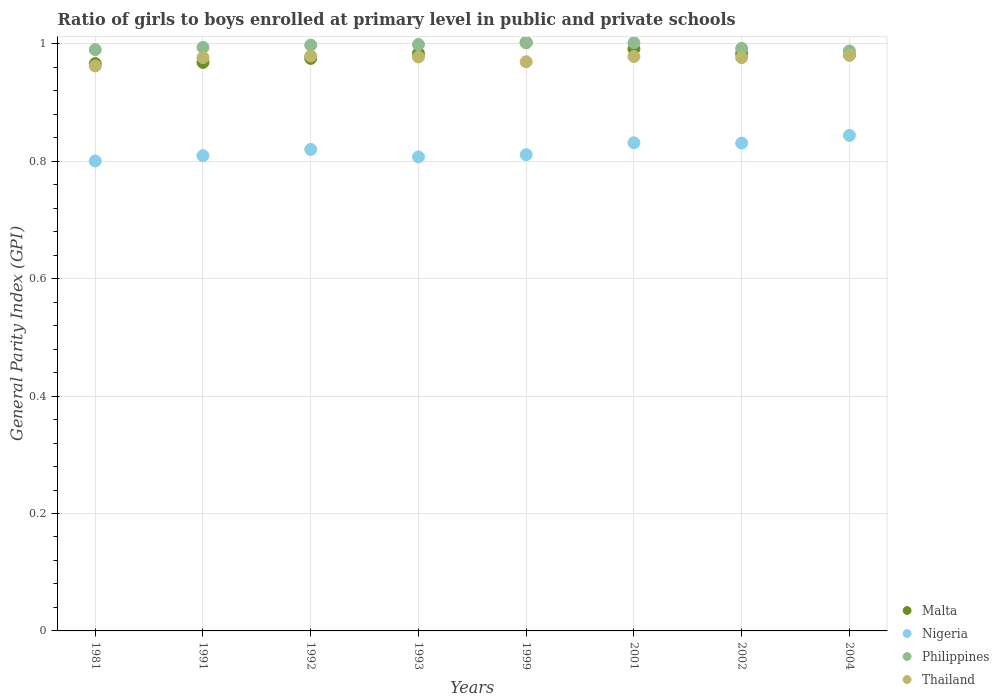What is the general parity index in Philippines in 2004?
Offer a very short reply. 0.99. Across all years, what is the maximum general parity index in Philippines?
Your answer should be compact. 1. Across all years, what is the minimum general parity index in Malta?
Ensure brevity in your answer.  0.97. In which year was the general parity index in Malta maximum?
Your answer should be compact. 1999. In which year was the general parity index in Philippines minimum?
Your answer should be very brief. 2004. What is the total general parity index in Malta in the graph?
Give a very brief answer. 7.85. What is the difference between the general parity index in Nigeria in 1991 and that in 1992?
Offer a terse response. -0.01. What is the difference between the general parity index in Thailand in 1993 and the general parity index in Philippines in 2001?
Keep it short and to the point. -0.02. What is the average general parity index in Thailand per year?
Provide a succinct answer. 0.98. In the year 1981, what is the difference between the general parity index in Philippines and general parity index in Nigeria?
Your answer should be compact. 0.19. In how many years, is the general parity index in Malta greater than 0.9600000000000001?
Your answer should be compact. 8. What is the ratio of the general parity index in Malta in 1981 to that in 1999?
Offer a very short reply. 0.96. Is the difference between the general parity index in Philippines in 1981 and 1993 greater than the difference between the general parity index in Nigeria in 1981 and 1993?
Provide a succinct answer. No. What is the difference between the highest and the second highest general parity index in Philippines?
Your response must be concise. 0. What is the difference between the highest and the lowest general parity index in Malta?
Provide a short and direct response. 0.04. Is the sum of the general parity index in Philippines in 1992 and 2001 greater than the maximum general parity index in Nigeria across all years?
Ensure brevity in your answer.  Yes. Is it the case that in every year, the sum of the general parity index in Malta and general parity index in Thailand  is greater than the sum of general parity index in Philippines and general parity index in Nigeria?
Ensure brevity in your answer.  Yes. How many dotlines are there?
Give a very brief answer. 4. What is the difference between two consecutive major ticks on the Y-axis?
Keep it short and to the point. 0.2. How are the legend labels stacked?
Your answer should be very brief. Vertical. What is the title of the graph?
Keep it short and to the point. Ratio of girls to boys enrolled at primary level in public and private schools. What is the label or title of the Y-axis?
Provide a succinct answer. General Parity Index (GPI). What is the General Parity Index (GPI) of Malta in 1981?
Give a very brief answer. 0.97. What is the General Parity Index (GPI) in Nigeria in 1981?
Your response must be concise. 0.8. What is the General Parity Index (GPI) of Philippines in 1981?
Keep it short and to the point. 0.99. What is the General Parity Index (GPI) in Thailand in 1981?
Your response must be concise. 0.96. What is the General Parity Index (GPI) in Malta in 1991?
Your answer should be very brief. 0.97. What is the General Parity Index (GPI) in Nigeria in 1991?
Your answer should be compact. 0.81. What is the General Parity Index (GPI) of Philippines in 1991?
Provide a short and direct response. 0.99. What is the General Parity Index (GPI) of Thailand in 1991?
Provide a succinct answer. 0.98. What is the General Parity Index (GPI) of Malta in 1992?
Give a very brief answer. 0.98. What is the General Parity Index (GPI) of Nigeria in 1992?
Keep it short and to the point. 0.82. What is the General Parity Index (GPI) in Philippines in 1992?
Offer a terse response. 1. What is the General Parity Index (GPI) in Thailand in 1992?
Offer a very short reply. 0.98. What is the General Parity Index (GPI) of Malta in 1993?
Give a very brief answer. 0.98. What is the General Parity Index (GPI) of Nigeria in 1993?
Offer a very short reply. 0.81. What is the General Parity Index (GPI) in Philippines in 1993?
Your answer should be very brief. 1. What is the General Parity Index (GPI) of Thailand in 1993?
Your response must be concise. 0.98. What is the General Parity Index (GPI) in Malta in 1999?
Your answer should be very brief. 1. What is the General Parity Index (GPI) of Nigeria in 1999?
Your answer should be compact. 0.81. What is the General Parity Index (GPI) of Philippines in 1999?
Your answer should be compact. 1. What is the General Parity Index (GPI) in Thailand in 1999?
Your answer should be very brief. 0.97. What is the General Parity Index (GPI) in Malta in 2001?
Ensure brevity in your answer.  0.99. What is the General Parity Index (GPI) in Nigeria in 2001?
Your response must be concise. 0.83. What is the General Parity Index (GPI) in Philippines in 2001?
Give a very brief answer. 1. What is the General Parity Index (GPI) in Thailand in 2001?
Ensure brevity in your answer.  0.98. What is the General Parity Index (GPI) in Malta in 2002?
Your answer should be very brief. 0.98. What is the General Parity Index (GPI) in Nigeria in 2002?
Offer a very short reply. 0.83. What is the General Parity Index (GPI) in Philippines in 2002?
Your response must be concise. 0.99. What is the General Parity Index (GPI) in Thailand in 2002?
Provide a short and direct response. 0.98. What is the General Parity Index (GPI) of Malta in 2004?
Your answer should be very brief. 0.98. What is the General Parity Index (GPI) of Nigeria in 2004?
Offer a terse response. 0.84. What is the General Parity Index (GPI) in Philippines in 2004?
Your response must be concise. 0.99. What is the General Parity Index (GPI) in Thailand in 2004?
Offer a terse response. 0.98. Across all years, what is the maximum General Parity Index (GPI) in Malta?
Ensure brevity in your answer.  1. Across all years, what is the maximum General Parity Index (GPI) of Nigeria?
Make the answer very short. 0.84. Across all years, what is the maximum General Parity Index (GPI) of Philippines?
Keep it short and to the point. 1. Across all years, what is the maximum General Parity Index (GPI) of Thailand?
Give a very brief answer. 0.98. Across all years, what is the minimum General Parity Index (GPI) in Malta?
Provide a succinct answer. 0.97. Across all years, what is the minimum General Parity Index (GPI) of Nigeria?
Your response must be concise. 0.8. Across all years, what is the minimum General Parity Index (GPI) of Philippines?
Make the answer very short. 0.99. Across all years, what is the minimum General Parity Index (GPI) of Thailand?
Your answer should be very brief. 0.96. What is the total General Parity Index (GPI) of Malta in the graph?
Offer a terse response. 7.85. What is the total General Parity Index (GPI) of Nigeria in the graph?
Provide a short and direct response. 6.55. What is the total General Parity Index (GPI) in Philippines in the graph?
Provide a succinct answer. 7.96. What is the total General Parity Index (GPI) of Thailand in the graph?
Your response must be concise. 7.8. What is the difference between the General Parity Index (GPI) in Malta in 1981 and that in 1991?
Provide a short and direct response. -0. What is the difference between the General Parity Index (GPI) in Nigeria in 1981 and that in 1991?
Provide a short and direct response. -0.01. What is the difference between the General Parity Index (GPI) in Philippines in 1981 and that in 1991?
Offer a very short reply. -0. What is the difference between the General Parity Index (GPI) of Thailand in 1981 and that in 1991?
Give a very brief answer. -0.01. What is the difference between the General Parity Index (GPI) in Malta in 1981 and that in 1992?
Your response must be concise. -0.01. What is the difference between the General Parity Index (GPI) of Nigeria in 1981 and that in 1992?
Provide a succinct answer. -0.02. What is the difference between the General Parity Index (GPI) of Philippines in 1981 and that in 1992?
Ensure brevity in your answer.  -0.01. What is the difference between the General Parity Index (GPI) of Thailand in 1981 and that in 1992?
Provide a short and direct response. -0.02. What is the difference between the General Parity Index (GPI) of Malta in 1981 and that in 1993?
Provide a short and direct response. -0.02. What is the difference between the General Parity Index (GPI) of Nigeria in 1981 and that in 1993?
Give a very brief answer. -0.01. What is the difference between the General Parity Index (GPI) of Philippines in 1981 and that in 1993?
Offer a terse response. -0.01. What is the difference between the General Parity Index (GPI) of Thailand in 1981 and that in 1993?
Your answer should be compact. -0.02. What is the difference between the General Parity Index (GPI) in Malta in 1981 and that in 1999?
Keep it short and to the point. -0.04. What is the difference between the General Parity Index (GPI) in Nigeria in 1981 and that in 1999?
Provide a short and direct response. -0.01. What is the difference between the General Parity Index (GPI) in Philippines in 1981 and that in 1999?
Give a very brief answer. -0.01. What is the difference between the General Parity Index (GPI) of Thailand in 1981 and that in 1999?
Give a very brief answer. -0.01. What is the difference between the General Parity Index (GPI) in Malta in 1981 and that in 2001?
Provide a short and direct response. -0.03. What is the difference between the General Parity Index (GPI) in Nigeria in 1981 and that in 2001?
Offer a terse response. -0.03. What is the difference between the General Parity Index (GPI) of Philippines in 1981 and that in 2001?
Provide a succinct answer. -0.01. What is the difference between the General Parity Index (GPI) of Thailand in 1981 and that in 2001?
Offer a very short reply. -0.02. What is the difference between the General Parity Index (GPI) of Malta in 1981 and that in 2002?
Make the answer very short. -0.02. What is the difference between the General Parity Index (GPI) of Nigeria in 1981 and that in 2002?
Provide a short and direct response. -0.03. What is the difference between the General Parity Index (GPI) of Philippines in 1981 and that in 2002?
Keep it short and to the point. -0. What is the difference between the General Parity Index (GPI) in Thailand in 1981 and that in 2002?
Keep it short and to the point. -0.01. What is the difference between the General Parity Index (GPI) in Malta in 1981 and that in 2004?
Offer a terse response. -0.01. What is the difference between the General Parity Index (GPI) in Nigeria in 1981 and that in 2004?
Offer a terse response. -0.04. What is the difference between the General Parity Index (GPI) of Philippines in 1981 and that in 2004?
Provide a succinct answer. 0. What is the difference between the General Parity Index (GPI) of Thailand in 1981 and that in 2004?
Ensure brevity in your answer.  -0.02. What is the difference between the General Parity Index (GPI) of Malta in 1991 and that in 1992?
Your response must be concise. -0.01. What is the difference between the General Parity Index (GPI) of Nigeria in 1991 and that in 1992?
Provide a succinct answer. -0.01. What is the difference between the General Parity Index (GPI) in Philippines in 1991 and that in 1992?
Keep it short and to the point. -0. What is the difference between the General Parity Index (GPI) in Thailand in 1991 and that in 1992?
Your answer should be compact. -0. What is the difference between the General Parity Index (GPI) in Malta in 1991 and that in 1993?
Offer a very short reply. -0.02. What is the difference between the General Parity Index (GPI) in Nigeria in 1991 and that in 1993?
Offer a terse response. 0. What is the difference between the General Parity Index (GPI) of Philippines in 1991 and that in 1993?
Give a very brief answer. -0.01. What is the difference between the General Parity Index (GPI) of Thailand in 1991 and that in 1993?
Your answer should be compact. -0. What is the difference between the General Parity Index (GPI) in Malta in 1991 and that in 1999?
Provide a succinct answer. -0.03. What is the difference between the General Parity Index (GPI) in Nigeria in 1991 and that in 1999?
Provide a short and direct response. -0. What is the difference between the General Parity Index (GPI) in Philippines in 1991 and that in 1999?
Offer a terse response. -0.01. What is the difference between the General Parity Index (GPI) in Thailand in 1991 and that in 1999?
Your response must be concise. 0.01. What is the difference between the General Parity Index (GPI) of Malta in 1991 and that in 2001?
Offer a very short reply. -0.02. What is the difference between the General Parity Index (GPI) of Nigeria in 1991 and that in 2001?
Give a very brief answer. -0.02. What is the difference between the General Parity Index (GPI) of Philippines in 1991 and that in 2001?
Offer a very short reply. -0.01. What is the difference between the General Parity Index (GPI) of Thailand in 1991 and that in 2001?
Your response must be concise. -0. What is the difference between the General Parity Index (GPI) in Malta in 1991 and that in 2002?
Provide a succinct answer. -0.01. What is the difference between the General Parity Index (GPI) in Nigeria in 1991 and that in 2002?
Provide a short and direct response. -0.02. What is the difference between the General Parity Index (GPI) of Philippines in 1991 and that in 2002?
Give a very brief answer. 0. What is the difference between the General Parity Index (GPI) of Thailand in 1991 and that in 2002?
Your answer should be compact. 0. What is the difference between the General Parity Index (GPI) in Malta in 1991 and that in 2004?
Your response must be concise. -0.01. What is the difference between the General Parity Index (GPI) in Nigeria in 1991 and that in 2004?
Provide a short and direct response. -0.03. What is the difference between the General Parity Index (GPI) in Philippines in 1991 and that in 2004?
Your answer should be compact. 0.01. What is the difference between the General Parity Index (GPI) of Thailand in 1991 and that in 2004?
Make the answer very short. -0. What is the difference between the General Parity Index (GPI) in Malta in 1992 and that in 1993?
Your answer should be compact. -0.01. What is the difference between the General Parity Index (GPI) of Nigeria in 1992 and that in 1993?
Ensure brevity in your answer.  0.01. What is the difference between the General Parity Index (GPI) of Philippines in 1992 and that in 1993?
Provide a short and direct response. -0. What is the difference between the General Parity Index (GPI) in Thailand in 1992 and that in 1993?
Offer a very short reply. 0. What is the difference between the General Parity Index (GPI) of Malta in 1992 and that in 1999?
Your answer should be very brief. -0.03. What is the difference between the General Parity Index (GPI) in Nigeria in 1992 and that in 1999?
Provide a short and direct response. 0.01. What is the difference between the General Parity Index (GPI) in Philippines in 1992 and that in 1999?
Ensure brevity in your answer.  -0. What is the difference between the General Parity Index (GPI) in Thailand in 1992 and that in 1999?
Your answer should be compact. 0.01. What is the difference between the General Parity Index (GPI) in Malta in 1992 and that in 2001?
Offer a very short reply. -0.02. What is the difference between the General Parity Index (GPI) of Nigeria in 1992 and that in 2001?
Make the answer very short. -0.01. What is the difference between the General Parity Index (GPI) of Philippines in 1992 and that in 2001?
Offer a very short reply. -0. What is the difference between the General Parity Index (GPI) of Thailand in 1992 and that in 2001?
Your response must be concise. 0. What is the difference between the General Parity Index (GPI) of Malta in 1992 and that in 2002?
Provide a short and direct response. -0.01. What is the difference between the General Parity Index (GPI) in Nigeria in 1992 and that in 2002?
Offer a terse response. -0.01. What is the difference between the General Parity Index (GPI) in Philippines in 1992 and that in 2002?
Your answer should be very brief. 0.01. What is the difference between the General Parity Index (GPI) in Thailand in 1992 and that in 2002?
Provide a short and direct response. 0. What is the difference between the General Parity Index (GPI) in Malta in 1992 and that in 2004?
Make the answer very short. -0.01. What is the difference between the General Parity Index (GPI) of Nigeria in 1992 and that in 2004?
Keep it short and to the point. -0.02. What is the difference between the General Parity Index (GPI) in Philippines in 1992 and that in 2004?
Your answer should be very brief. 0.01. What is the difference between the General Parity Index (GPI) in Thailand in 1992 and that in 2004?
Ensure brevity in your answer.  -0. What is the difference between the General Parity Index (GPI) in Malta in 1993 and that in 1999?
Make the answer very short. -0.02. What is the difference between the General Parity Index (GPI) in Nigeria in 1993 and that in 1999?
Your answer should be compact. -0. What is the difference between the General Parity Index (GPI) of Philippines in 1993 and that in 1999?
Keep it short and to the point. -0. What is the difference between the General Parity Index (GPI) of Thailand in 1993 and that in 1999?
Make the answer very short. 0.01. What is the difference between the General Parity Index (GPI) in Malta in 1993 and that in 2001?
Offer a terse response. -0.01. What is the difference between the General Parity Index (GPI) of Nigeria in 1993 and that in 2001?
Provide a succinct answer. -0.02. What is the difference between the General Parity Index (GPI) in Philippines in 1993 and that in 2001?
Ensure brevity in your answer.  -0. What is the difference between the General Parity Index (GPI) in Thailand in 1993 and that in 2001?
Provide a short and direct response. -0. What is the difference between the General Parity Index (GPI) in Nigeria in 1993 and that in 2002?
Your response must be concise. -0.02. What is the difference between the General Parity Index (GPI) of Philippines in 1993 and that in 2002?
Your answer should be compact. 0.01. What is the difference between the General Parity Index (GPI) of Thailand in 1993 and that in 2002?
Offer a very short reply. 0. What is the difference between the General Parity Index (GPI) in Malta in 1993 and that in 2004?
Give a very brief answer. 0. What is the difference between the General Parity Index (GPI) in Nigeria in 1993 and that in 2004?
Offer a very short reply. -0.04. What is the difference between the General Parity Index (GPI) of Philippines in 1993 and that in 2004?
Ensure brevity in your answer.  0.01. What is the difference between the General Parity Index (GPI) of Thailand in 1993 and that in 2004?
Offer a very short reply. -0. What is the difference between the General Parity Index (GPI) of Malta in 1999 and that in 2001?
Provide a succinct answer. 0.01. What is the difference between the General Parity Index (GPI) in Nigeria in 1999 and that in 2001?
Keep it short and to the point. -0.02. What is the difference between the General Parity Index (GPI) in Thailand in 1999 and that in 2001?
Ensure brevity in your answer.  -0.01. What is the difference between the General Parity Index (GPI) in Malta in 1999 and that in 2002?
Your response must be concise. 0.02. What is the difference between the General Parity Index (GPI) in Nigeria in 1999 and that in 2002?
Provide a short and direct response. -0.02. What is the difference between the General Parity Index (GPI) in Philippines in 1999 and that in 2002?
Provide a succinct answer. 0.01. What is the difference between the General Parity Index (GPI) in Thailand in 1999 and that in 2002?
Give a very brief answer. -0.01. What is the difference between the General Parity Index (GPI) in Malta in 1999 and that in 2004?
Your response must be concise. 0.02. What is the difference between the General Parity Index (GPI) of Nigeria in 1999 and that in 2004?
Keep it short and to the point. -0.03. What is the difference between the General Parity Index (GPI) in Philippines in 1999 and that in 2004?
Keep it short and to the point. 0.01. What is the difference between the General Parity Index (GPI) in Thailand in 1999 and that in 2004?
Give a very brief answer. -0.01. What is the difference between the General Parity Index (GPI) of Malta in 2001 and that in 2002?
Your response must be concise. 0.01. What is the difference between the General Parity Index (GPI) of Nigeria in 2001 and that in 2002?
Ensure brevity in your answer.  0. What is the difference between the General Parity Index (GPI) of Philippines in 2001 and that in 2002?
Provide a succinct answer. 0.01. What is the difference between the General Parity Index (GPI) in Thailand in 2001 and that in 2002?
Provide a short and direct response. 0. What is the difference between the General Parity Index (GPI) in Malta in 2001 and that in 2004?
Give a very brief answer. 0.01. What is the difference between the General Parity Index (GPI) of Nigeria in 2001 and that in 2004?
Offer a terse response. -0.01. What is the difference between the General Parity Index (GPI) in Philippines in 2001 and that in 2004?
Your response must be concise. 0.01. What is the difference between the General Parity Index (GPI) in Thailand in 2001 and that in 2004?
Give a very brief answer. -0. What is the difference between the General Parity Index (GPI) in Malta in 2002 and that in 2004?
Provide a succinct answer. 0. What is the difference between the General Parity Index (GPI) of Nigeria in 2002 and that in 2004?
Your answer should be very brief. -0.01. What is the difference between the General Parity Index (GPI) in Philippines in 2002 and that in 2004?
Your answer should be very brief. 0. What is the difference between the General Parity Index (GPI) in Thailand in 2002 and that in 2004?
Ensure brevity in your answer.  -0. What is the difference between the General Parity Index (GPI) in Malta in 1981 and the General Parity Index (GPI) in Nigeria in 1991?
Keep it short and to the point. 0.16. What is the difference between the General Parity Index (GPI) in Malta in 1981 and the General Parity Index (GPI) in Philippines in 1991?
Provide a short and direct response. -0.03. What is the difference between the General Parity Index (GPI) of Malta in 1981 and the General Parity Index (GPI) of Thailand in 1991?
Ensure brevity in your answer.  -0.01. What is the difference between the General Parity Index (GPI) of Nigeria in 1981 and the General Parity Index (GPI) of Philippines in 1991?
Give a very brief answer. -0.19. What is the difference between the General Parity Index (GPI) of Nigeria in 1981 and the General Parity Index (GPI) of Thailand in 1991?
Your answer should be compact. -0.18. What is the difference between the General Parity Index (GPI) of Philippines in 1981 and the General Parity Index (GPI) of Thailand in 1991?
Offer a terse response. 0.01. What is the difference between the General Parity Index (GPI) in Malta in 1981 and the General Parity Index (GPI) in Nigeria in 1992?
Your answer should be very brief. 0.15. What is the difference between the General Parity Index (GPI) in Malta in 1981 and the General Parity Index (GPI) in Philippines in 1992?
Offer a very short reply. -0.03. What is the difference between the General Parity Index (GPI) in Malta in 1981 and the General Parity Index (GPI) in Thailand in 1992?
Your answer should be very brief. -0.01. What is the difference between the General Parity Index (GPI) in Nigeria in 1981 and the General Parity Index (GPI) in Philippines in 1992?
Ensure brevity in your answer.  -0.2. What is the difference between the General Parity Index (GPI) of Nigeria in 1981 and the General Parity Index (GPI) of Thailand in 1992?
Give a very brief answer. -0.18. What is the difference between the General Parity Index (GPI) in Philippines in 1981 and the General Parity Index (GPI) in Thailand in 1992?
Your answer should be very brief. 0.01. What is the difference between the General Parity Index (GPI) of Malta in 1981 and the General Parity Index (GPI) of Nigeria in 1993?
Offer a terse response. 0.16. What is the difference between the General Parity Index (GPI) in Malta in 1981 and the General Parity Index (GPI) in Philippines in 1993?
Make the answer very short. -0.03. What is the difference between the General Parity Index (GPI) of Malta in 1981 and the General Parity Index (GPI) of Thailand in 1993?
Provide a succinct answer. -0.01. What is the difference between the General Parity Index (GPI) in Nigeria in 1981 and the General Parity Index (GPI) in Philippines in 1993?
Provide a short and direct response. -0.2. What is the difference between the General Parity Index (GPI) in Nigeria in 1981 and the General Parity Index (GPI) in Thailand in 1993?
Offer a very short reply. -0.18. What is the difference between the General Parity Index (GPI) in Philippines in 1981 and the General Parity Index (GPI) in Thailand in 1993?
Offer a very short reply. 0.01. What is the difference between the General Parity Index (GPI) in Malta in 1981 and the General Parity Index (GPI) in Nigeria in 1999?
Keep it short and to the point. 0.15. What is the difference between the General Parity Index (GPI) of Malta in 1981 and the General Parity Index (GPI) of Philippines in 1999?
Provide a succinct answer. -0.04. What is the difference between the General Parity Index (GPI) of Malta in 1981 and the General Parity Index (GPI) of Thailand in 1999?
Keep it short and to the point. -0. What is the difference between the General Parity Index (GPI) in Nigeria in 1981 and the General Parity Index (GPI) in Philippines in 1999?
Offer a very short reply. -0.2. What is the difference between the General Parity Index (GPI) in Nigeria in 1981 and the General Parity Index (GPI) in Thailand in 1999?
Provide a succinct answer. -0.17. What is the difference between the General Parity Index (GPI) in Philippines in 1981 and the General Parity Index (GPI) in Thailand in 1999?
Give a very brief answer. 0.02. What is the difference between the General Parity Index (GPI) in Malta in 1981 and the General Parity Index (GPI) in Nigeria in 2001?
Give a very brief answer. 0.13. What is the difference between the General Parity Index (GPI) in Malta in 1981 and the General Parity Index (GPI) in Philippines in 2001?
Your answer should be compact. -0.04. What is the difference between the General Parity Index (GPI) of Malta in 1981 and the General Parity Index (GPI) of Thailand in 2001?
Make the answer very short. -0.01. What is the difference between the General Parity Index (GPI) in Nigeria in 1981 and the General Parity Index (GPI) in Philippines in 2001?
Your answer should be very brief. -0.2. What is the difference between the General Parity Index (GPI) of Nigeria in 1981 and the General Parity Index (GPI) of Thailand in 2001?
Your response must be concise. -0.18. What is the difference between the General Parity Index (GPI) of Philippines in 1981 and the General Parity Index (GPI) of Thailand in 2001?
Offer a very short reply. 0.01. What is the difference between the General Parity Index (GPI) in Malta in 1981 and the General Parity Index (GPI) in Nigeria in 2002?
Provide a succinct answer. 0.14. What is the difference between the General Parity Index (GPI) in Malta in 1981 and the General Parity Index (GPI) in Philippines in 2002?
Offer a terse response. -0.03. What is the difference between the General Parity Index (GPI) in Malta in 1981 and the General Parity Index (GPI) in Thailand in 2002?
Provide a succinct answer. -0.01. What is the difference between the General Parity Index (GPI) in Nigeria in 1981 and the General Parity Index (GPI) in Philippines in 2002?
Your answer should be compact. -0.19. What is the difference between the General Parity Index (GPI) in Nigeria in 1981 and the General Parity Index (GPI) in Thailand in 2002?
Make the answer very short. -0.18. What is the difference between the General Parity Index (GPI) in Philippines in 1981 and the General Parity Index (GPI) in Thailand in 2002?
Your answer should be compact. 0.01. What is the difference between the General Parity Index (GPI) in Malta in 1981 and the General Parity Index (GPI) in Nigeria in 2004?
Make the answer very short. 0.12. What is the difference between the General Parity Index (GPI) of Malta in 1981 and the General Parity Index (GPI) of Philippines in 2004?
Give a very brief answer. -0.02. What is the difference between the General Parity Index (GPI) of Malta in 1981 and the General Parity Index (GPI) of Thailand in 2004?
Your response must be concise. -0.01. What is the difference between the General Parity Index (GPI) in Nigeria in 1981 and the General Parity Index (GPI) in Philippines in 2004?
Ensure brevity in your answer.  -0.19. What is the difference between the General Parity Index (GPI) in Nigeria in 1981 and the General Parity Index (GPI) in Thailand in 2004?
Offer a very short reply. -0.18. What is the difference between the General Parity Index (GPI) of Philippines in 1981 and the General Parity Index (GPI) of Thailand in 2004?
Offer a very short reply. 0.01. What is the difference between the General Parity Index (GPI) of Malta in 1991 and the General Parity Index (GPI) of Nigeria in 1992?
Provide a succinct answer. 0.15. What is the difference between the General Parity Index (GPI) in Malta in 1991 and the General Parity Index (GPI) in Philippines in 1992?
Keep it short and to the point. -0.03. What is the difference between the General Parity Index (GPI) in Malta in 1991 and the General Parity Index (GPI) in Thailand in 1992?
Give a very brief answer. -0.01. What is the difference between the General Parity Index (GPI) in Nigeria in 1991 and the General Parity Index (GPI) in Philippines in 1992?
Keep it short and to the point. -0.19. What is the difference between the General Parity Index (GPI) of Nigeria in 1991 and the General Parity Index (GPI) of Thailand in 1992?
Your answer should be compact. -0.17. What is the difference between the General Parity Index (GPI) in Philippines in 1991 and the General Parity Index (GPI) in Thailand in 1992?
Offer a terse response. 0.01. What is the difference between the General Parity Index (GPI) in Malta in 1991 and the General Parity Index (GPI) in Nigeria in 1993?
Offer a very short reply. 0.16. What is the difference between the General Parity Index (GPI) of Malta in 1991 and the General Parity Index (GPI) of Philippines in 1993?
Keep it short and to the point. -0.03. What is the difference between the General Parity Index (GPI) in Malta in 1991 and the General Parity Index (GPI) in Thailand in 1993?
Provide a short and direct response. -0.01. What is the difference between the General Parity Index (GPI) of Nigeria in 1991 and the General Parity Index (GPI) of Philippines in 1993?
Provide a short and direct response. -0.19. What is the difference between the General Parity Index (GPI) of Nigeria in 1991 and the General Parity Index (GPI) of Thailand in 1993?
Keep it short and to the point. -0.17. What is the difference between the General Parity Index (GPI) in Philippines in 1991 and the General Parity Index (GPI) in Thailand in 1993?
Keep it short and to the point. 0.02. What is the difference between the General Parity Index (GPI) of Malta in 1991 and the General Parity Index (GPI) of Nigeria in 1999?
Provide a succinct answer. 0.16. What is the difference between the General Parity Index (GPI) of Malta in 1991 and the General Parity Index (GPI) of Philippines in 1999?
Ensure brevity in your answer.  -0.03. What is the difference between the General Parity Index (GPI) in Malta in 1991 and the General Parity Index (GPI) in Thailand in 1999?
Make the answer very short. -0. What is the difference between the General Parity Index (GPI) in Nigeria in 1991 and the General Parity Index (GPI) in Philippines in 1999?
Ensure brevity in your answer.  -0.19. What is the difference between the General Parity Index (GPI) in Nigeria in 1991 and the General Parity Index (GPI) in Thailand in 1999?
Offer a very short reply. -0.16. What is the difference between the General Parity Index (GPI) in Philippines in 1991 and the General Parity Index (GPI) in Thailand in 1999?
Your answer should be compact. 0.02. What is the difference between the General Parity Index (GPI) in Malta in 1991 and the General Parity Index (GPI) in Nigeria in 2001?
Offer a terse response. 0.14. What is the difference between the General Parity Index (GPI) of Malta in 1991 and the General Parity Index (GPI) of Philippines in 2001?
Offer a terse response. -0.03. What is the difference between the General Parity Index (GPI) in Malta in 1991 and the General Parity Index (GPI) in Thailand in 2001?
Offer a terse response. -0.01. What is the difference between the General Parity Index (GPI) of Nigeria in 1991 and the General Parity Index (GPI) of Philippines in 2001?
Your answer should be very brief. -0.19. What is the difference between the General Parity Index (GPI) in Nigeria in 1991 and the General Parity Index (GPI) in Thailand in 2001?
Keep it short and to the point. -0.17. What is the difference between the General Parity Index (GPI) of Philippines in 1991 and the General Parity Index (GPI) of Thailand in 2001?
Make the answer very short. 0.02. What is the difference between the General Parity Index (GPI) of Malta in 1991 and the General Parity Index (GPI) of Nigeria in 2002?
Your answer should be compact. 0.14. What is the difference between the General Parity Index (GPI) of Malta in 1991 and the General Parity Index (GPI) of Philippines in 2002?
Keep it short and to the point. -0.02. What is the difference between the General Parity Index (GPI) of Malta in 1991 and the General Parity Index (GPI) of Thailand in 2002?
Give a very brief answer. -0.01. What is the difference between the General Parity Index (GPI) in Nigeria in 1991 and the General Parity Index (GPI) in Philippines in 2002?
Give a very brief answer. -0.18. What is the difference between the General Parity Index (GPI) in Nigeria in 1991 and the General Parity Index (GPI) in Thailand in 2002?
Your answer should be compact. -0.17. What is the difference between the General Parity Index (GPI) of Philippines in 1991 and the General Parity Index (GPI) of Thailand in 2002?
Give a very brief answer. 0.02. What is the difference between the General Parity Index (GPI) of Malta in 1991 and the General Parity Index (GPI) of Nigeria in 2004?
Your answer should be compact. 0.12. What is the difference between the General Parity Index (GPI) in Malta in 1991 and the General Parity Index (GPI) in Philippines in 2004?
Your response must be concise. -0.02. What is the difference between the General Parity Index (GPI) of Malta in 1991 and the General Parity Index (GPI) of Thailand in 2004?
Keep it short and to the point. -0.01. What is the difference between the General Parity Index (GPI) in Nigeria in 1991 and the General Parity Index (GPI) in Philippines in 2004?
Your answer should be compact. -0.18. What is the difference between the General Parity Index (GPI) in Nigeria in 1991 and the General Parity Index (GPI) in Thailand in 2004?
Your answer should be very brief. -0.17. What is the difference between the General Parity Index (GPI) in Philippines in 1991 and the General Parity Index (GPI) in Thailand in 2004?
Ensure brevity in your answer.  0.01. What is the difference between the General Parity Index (GPI) in Malta in 1992 and the General Parity Index (GPI) in Nigeria in 1993?
Give a very brief answer. 0.17. What is the difference between the General Parity Index (GPI) of Malta in 1992 and the General Parity Index (GPI) of Philippines in 1993?
Keep it short and to the point. -0.02. What is the difference between the General Parity Index (GPI) in Malta in 1992 and the General Parity Index (GPI) in Thailand in 1993?
Make the answer very short. -0. What is the difference between the General Parity Index (GPI) of Nigeria in 1992 and the General Parity Index (GPI) of Philippines in 1993?
Offer a terse response. -0.18. What is the difference between the General Parity Index (GPI) in Nigeria in 1992 and the General Parity Index (GPI) in Thailand in 1993?
Offer a terse response. -0.16. What is the difference between the General Parity Index (GPI) in Philippines in 1992 and the General Parity Index (GPI) in Thailand in 1993?
Your answer should be compact. 0.02. What is the difference between the General Parity Index (GPI) in Malta in 1992 and the General Parity Index (GPI) in Nigeria in 1999?
Ensure brevity in your answer.  0.16. What is the difference between the General Parity Index (GPI) in Malta in 1992 and the General Parity Index (GPI) in Philippines in 1999?
Provide a short and direct response. -0.03. What is the difference between the General Parity Index (GPI) of Malta in 1992 and the General Parity Index (GPI) of Thailand in 1999?
Your response must be concise. 0.01. What is the difference between the General Parity Index (GPI) of Nigeria in 1992 and the General Parity Index (GPI) of Philippines in 1999?
Offer a very short reply. -0.18. What is the difference between the General Parity Index (GPI) of Nigeria in 1992 and the General Parity Index (GPI) of Thailand in 1999?
Give a very brief answer. -0.15. What is the difference between the General Parity Index (GPI) in Philippines in 1992 and the General Parity Index (GPI) in Thailand in 1999?
Provide a succinct answer. 0.03. What is the difference between the General Parity Index (GPI) in Malta in 1992 and the General Parity Index (GPI) in Nigeria in 2001?
Ensure brevity in your answer.  0.14. What is the difference between the General Parity Index (GPI) in Malta in 1992 and the General Parity Index (GPI) in Philippines in 2001?
Provide a short and direct response. -0.03. What is the difference between the General Parity Index (GPI) in Malta in 1992 and the General Parity Index (GPI) in Thailand in 2001?
Your response must be concise. -0. What is the difference between the General Parity Index (GPI) in Nigeria in 1992 and the General Parity Index (GPI) in Philippines in 2001?
Your answer should be very brief. -0.18. What is the difference between the General Parity Index (GPI) in Nigeria in 1992 and the General Parity Index (GPI) in Thailand in 2001?
Make the answer very short. -0.16. What is the difference between the General Parity Index (GPI) in Philippines in 1992 and the General Parity Index (GPI) in Thailand in 2001?
Your response must be concise. 0.02. What is the difference between the General Parity Index (GPI) of Malta in 1992 and the General Parity Index (GPI) of Nigeria in 2002?
Your answer should be very brief. 0.14. What is the difference between the General Parity Index (GPI) in Malta in 1992 and the General Parity Index (GPI) in Philippines in 2002?
Offer a very short reply. -0.02. What is the difference between the General Parity Index (GPI) in Malta in 1992 and the General Parity Index (GPI) in Thailand in 2002?
Your answer should be compact. -0. What is the difference between the General Parity Index (GPI) of Nigeria in 1992 and the General Parity Index (GPI) of Philippines in 2002?
Keep it short and to the point. -0.17. What is the difference between the General Parity Index (GPI) of Nigeria in 1992 and the General Parity Index (GPI) of Thailand in 2002?
Make the answer very short. -0.16. What is the difference between the General Parity Index (GPI) of Philippines in 1992 and the General Parity Index (GPI) of Thailand in 2002?
Your answer should be very brief. 0.02. What is the difference between the General Parity Index (GPI) in Malta in 1992 and the General Parity Index (GPI) in Nigeria in 2004?
Keep it short and to the point. 0.13. What is the difference between the General Parity Index (GPI) of Malta in 1992 and the General Parity Index (GPI) of Philippines in 2004?
Your answer should be compact. -0.01. What is the difference between the General Parity Index (GPI) of Malta in 1992 and the General Parity Index (GPI) of Thailand in 2004?
Offer a very short reply. -0.01. What is the difference between the General Parity Index (GPI) of Nigeria in 1992 and the General Parity Index (GPI) of Philippines in 2004?
Provide a succinct answer. -0.17. What is the difference between the General Parity Index (GPI) in Nigeria in 1992 and the General Parity Index (GPI) in Thailand in 2004?
Give a very brief answer. -0.16. What is the difference between the General Parity Index (GPI) of Philippines in 1992 and the General Parity Index (GPI) of Thailand in 2004?
Your answer should be very brief. 0.02. What is the difference between the General Parity Index (GPI) in Malta in 1993 and the General Parity Index (GPI) in Nigeria in 1999?
Keep it short and to the point. 0.17. What is the difference between the General Parity Index (GPI) in Malta in 1993 and the General Parity Index (GPI) in Philippines in 1999?
Offer a terse response. -0.02. What is the difference between the General Parity Index (GPI) in Malta in 1993 and the General Parity Index (GPI) in Thailand in 1999?
Offer a very short reply. 0.01. What is the difference between the General Parity Index (GPI) of Nigeria in 1993 and the General Parity Index (GPI) of Philippines in 1999?
Offer a very short reply. -0.19. What is the difference between the General Parity Index (GPI) of Nigeria in 1993 and the General Parity Index (GPI) of Thailand in 1999?
Make the answer very short. -0.16. What is the difference between the General Parity Index (GPI) of Philippines in 1993 and the General Parity Index (GPI) of Thailand in 1999?
Your response must be concise. 0.03. What is the difference between the General Parity Index (GPI) of Malta in 1993 and the General Parity Index (GPI) of Nigeria in 2001?
Offer a very short reply. 0.15. What is the difference between the General Parity Index (GPI) of Malta in 1993 and the General Parity Index (GPI) of Philippines in 2001?
Offer a terse response. -0.02. What is the difference between the General Parity Index (GPI) of Malta in 1993 and the General Parity Index (GPI) of Thailand in 2001?
Provide a succinct answer. 0.01. What is the difference between the General Parity Index (GPI) of Nigeria in 1993 and the General Parity Index (GPI) of Philippines in 2001?
Offer a very short reply. -0.19. What is the difference between the General Parity Index (GPI) in Nigeria in 1993 and the General Parity Index (GPI) in Thailand in 2001?
Ensure brevity in your answer.  -0.17. What is the difference between the General Parity Index (GPI) of Philippines in 1993 and the General Parity Index (GPI) of Thailand in 2001?
Provide a short and direct response. 0.02. What is the difference between the General Parity Index (GPI) of Malta in 1993 and the General Parity Index (GPI) of Nigeria in 2002?
Give a very brief answer. 0.15. What is the difference between the General Parity Index (GPI) in Malta in 1993 and the General Parity Index (GPI) in Philippines in 2002?
Offer a very short reply. -0.01. What is the difference between the General Parity Index (GPI) in Malta in 1993 and the General Parity Index (GPI) in Thailand in 2002?
Provide a succinct answer. 0.01. What is the difference between the General Parity Index (GPI) in Nigeria in 1993 and the General Parity Index (GPI) in Philippines in 2002?
Offer a terse response. -0.18. What is the difference between the General Parity Index (GPI) in Nigeria in 1993 and the General Parity Index (GPI) in Thailand in 2002?
Your answer should be very brief. -0.17. What is the difference between the General Parity Index (GPI) of Philippines in 1993 and the General Parity Index (GPI) of Thailand in 2002?
Offer a very short reply. 0.02. What is the difference between the General Parity Index (GPI) in Malta in 1993 and the General Parity Index (GPI) in Nigeria in 2004?
Offer a very short reply. 0.14. What is the difference between the General Parity Index (GPI) in Malta in 1993 and the General Parity Index (GPI) in Philippines in 2004?
Ensure brevity in your answer.  -0. What is the difference between the General Parity Index (GPI) of Malta in 1993 and the General Parity Index (GPI) of Thailand in 2004?
Keep it short and to the point. 0. What is the difference between the General Parity Index (GPI) in Nigeria in 1993 and the General Parity Index (GPI) in Philippines in 2004?
Your response must be concise. -0.18. What is the difference between the General Parity Index (GPI) in Nigeria in 1993 and the General Parity Index (GPI) in Thailand in 2004?
Keep it short and to the point. -0.17. What is the difference between the General Parity Index (GPI) in Philippines in 1993 and the General Parity Index (GPI) in Thailand in 2004?
Your answer should be compact. 0.02. What is the difference between the General Parity Index (GPI) in Malta in 1999 and the General Parity Index (GPI) in Nigeria in 2001?
Your answer should be very brief. 0.17. What is the difference between the General Parity Index (GPI) in Malta in 1999 and the General Parity Index (GPI) in Philippines in 2001?
Provide a succinct answer. 0. What is the difference between the General Parity Index (GPI) in Malta in 1999 and the General Parity Index (GPI) in Thailand in 2001?
Your answer should be compact. 0.02. What is the difference between the General Parity Index (GPI) in Nigeria in 1999 and the General Parity Index (GPI) in Philippines in 2001?
Your answer should be compact. -0.19. What is the difference between the General Parity Index (GPI) in Nigeria in 1999 and the General Parity Index (GPI) in Thailand in 2001?
Make the answer very short. -0.17. What is the difference between the General Parity Index (GPI) in Philippines in 1999 and the General Parity Index (GPI) in Thailand in 2001?
Offer a terse response. 0.02. What is the difference between the General Parity Index (GPI) of Malta in 1999 and the General Parity Index (GPI) of Nigeria in 2002?
Ensure brevity in your answer.  0.17. What is the difference between the General Parity Index (GPI) of Malta in 1999 and the General Parity Index (GPI) of Philippines in 2002?
Offer a very short reply. 0.01. What is the difference between the General Parity Index (GPI) in Malta in 1999 and the General Parity Index (GPI) in Thailand in 2002?
Provide a short and direct response. 0.03. What is the difference between the General Parity Index (GPI) in Nigeria in 1999 and the General Parity Index (GPI) in Philippines in 2002?
Your answer should be compact. -0.18. What is the difference between the General Parity Index (GPI) of Nigeria in 1999 and the General Parity Index (GPI) of Thailand in 2002?
Your response must be concise. -0.17. What is the difference between the General Parity Index (GPI) of Philippines in 1999 and the General Parity Index (GPI) of Thailand in 2002?
Provide a short and direct response. 0.03. What is the difference between the General Parity Index (GPI) of Malta in 1999 and the General Parity Index (GPI) of Nigeria in 2004?
Ensure brevity in your answer.  0.16. What is the difference between the General Parity Index (GPI) in Malta in 1999 and the General Parity Index (GPI) in Philippines in 2004?
Offer a very short reply. 0.01. What is the difference between the General Parity Index (GPI) in Malta in 1999 and the General Parity Index (GPI) in Thailand in 2004?
Offer a very short reply. 0.02. What is the difference between the General Parity Index (GPI) in Nigeria in 1999 and the General Parity Index (GPI) in Philippines in 2004?
Provide a succinct answer. -0.18. What is the difference between the General Parity Index (GPI) of Nigeria in 1999 and the General Parity Index (GPI) of Thailand in 2004?
Make the answer very short. -0.17. What is the difference between the General Parity Index (GPI) of Philippines in 1999 and the General Parity Index (GPI) of Thailand in 2004?
Your answer should be compact. 0.02. What is the difference between the General Parity Index (GPI) of Malta in 2001 and the General Parity Index (GPI) of Nigeria in 2002?
Offer a terse response. 0.16. What is the difference between the General Parity Index (GPI) of Malta in 2001 and the General Parity Index (GPI) of Philippines in 2002?
Give a very brief answer. -0. What is the difference between the General Parity Index (GPI) of Malta in 2001 and the General Parity Index (GPI) of Thailand in 2002?
Provide a succinct answer. 0.01. What is the difference between the General Parity Index (GPI) of Nigeria in 2001 and the General Parity Index (GPI) of Philippines in 2002?
Your answer should be compact. -0.16. What is the difference between the General Parity Index (GPI) of Nigeria in 2001 and the General Parity Index (GPI) of Thailand in 2002?
Make the answer very short. -0.14. What is the difference between the General Parity Index (GPI) of Philippines in 2001 and the General Parity Index (GPI) of Thailand in 2002?
Your answer should be compact. 0.03. What is the difference between the General Parity Index (GPI) of Malta in 2001 and the General Parity Index (GPI) of Nigeria in 2004?
Your answer should be very brief. 0.15. What is the difference between the General Parity Index (GPI) of Malta in 2001 and the General Parity Index (GPI) of Philippines in 2004?
Your answer should be very brief. 0. What is the difference between the General Parity Index (GPI) of Malta in 2001 and the General Parity Index (GPI) of Thailand in 2004?
Offer a terse response. 0.01. What is the difference between the General Parity Index (GPI) of Nigeria in 2001 and the General Parity Index (GPI) of Philippines in 2004?
Offer a terse response. -0.16. What is the difference between the General Parity Index (GPI) in Nigeria in 2001 and the General Parity Index (GPI) in Thailand in 2004?
Your answer should be very brief. -0.15. What is the difference between the General Parity Index (GPI) of Philippines in 2001 and the General Parity Index (GPI) of Thailand in 2004?
Make the answer very short. 0.02. What is the difference between the General Parity Index (GPI) of Malta in 2002 and the General Parity Index (GPI) of Nigeria in 2004?
Provide a succinct answer. 0.14. What is the difference between the General Parity Index (GPI) in Malta in 2002 and the General Parity Index (GPI) in Philippines in 2004?
Provide a succinct answer. -0. What is the difference between the General Parity Index (GPI) of Malta in 2002 and the General Parity Index (GPI) of Thailand in 2004?
Offer a very short reply. 0. What is the difference between the General Parity Index (GPI) of Nigeria in 2002 and the General Parity Index (GPI) of Philippines in 2004?
Provide a succinct answer. -0.16. What is the difference between the General Parity Index (GPI) in Nigeria in 2002 and the General Parity Index (GPI) in Thailand in 2004?
Offer a very short reply. -0.15. What is the difference between the General Parity Index (GPI) of Philippines in 2002 and the General Parity Index (GPI) of Thailand in 2004?
Your answer should be compact. 0.01. What is the average General Parity Index (GPI) of Malta per year?
Offer a terse response. 0.98. What is the average General Parity Index (GPI) of Nigeria per year?
Make the answer very short. 0.82. What is the average General Parity Index (GPI) in Thailand per year?
Provide a succinct answer. 0.97. In the year 1981, what is the difference between the General Parity Index (GPI) of Malta and General Parity Index (GPI) of Nigeria?
Keep it short and to the point. 0.17. In the year 1981, what is the difference between the General Parity Index (GPI) in Malta and General Parity Index (GPI) in Philippines?
Give a very brief answer. -0.02. In the year 1981, what is the difference between the General Parity Index (GPI) in Malta and General Parity Index (GPI) in Thailand?
Your answer should be very brief. 0. In the year 1981, what is the difference between the General Parity Index (GPI) in Nigeria and General Parity Index (GPI) in Philippines?
Make the answer very short. -0.19. In the year 1981, what is the difference between the General Parity Index (GPI) of Nigeria and General Parity Index (GPI) of Thailand?
Offer a very short reply. -0.16. In the year 1981, what is the difference between the General Parity Index (GPI) in Philippines and General Parity Index (GPI) in Thailand?
Your answer should be very brief. 0.03. In the year 1991, what is the difference between the General Parity Index (GPI) of Malta and General Parity Index (GPI) of Nigeria?
Offer a terse response. 0.16. In the year 1991, what is the difference between the General Parity Index (GPI) in Malta and General Parity Index (GPI) in Philippines?
Your answer should be very brief. -0.03. In the year 1991, what is the difference between the General Parity Index (GPI) in Malta and General Parity Index (GPI) in Thailand?
Your answer should be very brief. -0.01. In the year 1991, what is the difference between the General Parity Index (GPI) of Nigeria and General Parity Index (GPI) of Philippines?
Provide a succinct answer. -0.18. In the year 1991, what is the difference between the General Parity Index (GPI) of Nigeria and General Parity Index (GPI) of Thailand?
Make the answer very short. -0.17. In the year 1991, what is the difference between the General Parity Index (GPI) in Philippines and General Parity Index (GPI) in Thailand?
Offer a terse response. 0.02. In the year 1992, what is the difference between the General Parity Index (GPI) in Malta and General Parity Index (GPI) in Nigeria?
Make the answer very short. 0.15. In the year 1992, what is the difference between the General Parity Index (GPI) of Malta and General Parity Index (GPI) of Philippines?
Offer a terse response. -0.02. In the year 1992, what is the difference between the General Parity Index (GPI) in Malta and General Parity Index (GPI) in Thailand?
Provide a succinct answer. -0. In the year 1992, what is the difference between the General Parity Index (GPI) in Nigeria and General Parity Index (GPI) in Philippines?
Ensure brevity in your answer.  -0.18. In the year 1992, what is the difference between the General Parity Index (GPI) of Nigeria and General Parity Index (GPI) of Thailand?
Ensure brevity in your answer.  -0.16. In the year 1992, what is the difference between the General Parity Index (GPI) in Philippines and General Parity Index (GPI) in Thailand?
Your response must be concise. 0.02. In the year 1993, what is the difference between the General Parity Index (GPI) in Malta and General Parity Index (GPI) in Nigeria?
Provide a short and direct response. 0.18. In the year 1993, what is the difference between the General Parity Index (GPI) in Malta and General Parity Index (GPI) in Philippines?
Your answer should be very brief. -0.02. In the year 1993, what is the difference between the General Parity Index (GPI) in Malta and General Parity Index (GPI) in Thailand?
Keep it short and to the point. 0.01. In the year 1993, what is the difference between the General Parity Index (GPI) of Nigeria and General Parity Index (GPI) of Philippines?
Offer a very short reply. -0.19. In the year 1993, what is the difference between the General Parity Index (GPI) of Nigeria and General Parity Index (GPI) of Thailand?
Your answer should be compact. -0.17. In the year 1993, what is the difference between the General Parity Index (GPI) of Philippines and General Parity Index (GPI) of Thailand?
Give a very brief answer. 0.02. In the year 1999, what is the difference between the General Parity Index (GPI) of Malta and General Parity Index (GPI) of Nigeria?
Offer a very short reply. 0.19. In the year 1999, what is the difference between the General Parity Index (GPI) in Malta and General Parity Index (GPI) in Philippines?
Give a very brief answer. 0. In the year 1999, what is the difference between the General Parity Index (GPI) in Malta and General Parity Index (GPI) in Thailand?
Provide a succinct answer. 0.03. In the year 1999, what is the difference between the General Parity Index (GPI) in Nigeria and General Parity Index (GPI) in Philippines?
Provide a succinct answer. -0.19. In the year 1999, what is the difference between the General Parity Index (GPI) in Nigeria and General Parity Index (GPI) in Thailand?
Provide a succinct answer. -0.16. In the year 1999, what is the difference between the General Parity Index (GPI) in Philippines and General Parity Index (GPI) in Thailand?
Offer a very short reply. 0.03. In the year 2001, what is the difference between the General Parity Index (GPI) in Malta and General Parity Index (GPI) in Nigeria?
Keep it short and to the point. 0.16. In the year 2001, what is the difference between the General Parity Index (GPI) of Malta and General Parity Index (GPI) of Philippines?
Make the answer very short. -0.01. In the year 2001, what is the difference between the General Parity Index (GPI) of Malta and General Parity Index (GPI) of Thailand?
Your answer should be compact. 0.01. In the year 2001, what is the difference between the General Parity Index (GPI) in Nigeria and General Parity Index (GPI) in Philippines?
Provide a short and direct response. -0.17. In the year 2001, what is the difference between the General Parity Index (GPI) in Nigeria and General Parity Index (GPI) in Thailand?
Provide a short and direct response. -0.15. In the year 2001, what is the difference between the General Parity Index (GPI) in Philippines and General Parity Index (GPI) in Thailand?
Keep it short and to the point. 0.02. In the year 2002, what is the difference between the General Parity Index (GPI) of Malta and General Parity Index (GPI) of Nigeria?
Give a very brief answer. 0.15. In the year 2002, what is the difference between the General Parity Index (GPI) in Malta and General Parity Index (GPI) in Philippines?
Your answer should be compact. -0.01. In the year 2002, what is the difference between the General Parity Index (GPI) in Malta and General Parity Index (GPI) in Thailand?
Make the answer very short. 0.01. In the year 2002, what is the difference between the General Parity Index (GPI) of Nigeria and General Parity Index (GPI) of Philippines?
Give a very brief answer. -0.16. In the year 2002, what is the difference between the General Parity Index (GPI) in Nigeria and General Parity Index (GPI) in Thailand?
Ensure brevity in your answer.  -0.15. In the year 2002, what is the difference between the General Parity Index (GPI) in Philippines and General Parity Index (GPI) in Thailand?
Offer a terse response. 0.02. In the year 2004, what is the difference between the General Parity Index (GPI) in Malta and General Parity Index (GPI) in Nigeria?
Offer a terse response. 0.14. In the year 2004, what is the difference between the General Parity Index (GPI) in Malta and General Parity Index (GPI) in Philippines?
Offer a terse response. -0.01. In the year 2004, what is the difference between the General Parity Index (GPI) in Nigeria and General Parity Index (GPI) in Philippines?
Make the answer very short. -0.14. In the year 2004, what is the difference between the General Parity Index (GPI) of Nigeria and General Parity Index (GPI) of Thailand?
Your answer should be very brief. -0.14. In the year 2004, what is the difference between the General Parity Index (GPI) of Philippines and General Parity Index (GPI) of Thailand?
Your answer should be very brief. 0.01. What is the ratio of the General Parity Index (GPI) in Malta in 1981 to that in 1991?
Your answer should be very brief. 1. What is the ratio of the General Parity Index (GPI) in Philippines in 1981 to that in 1991?
Ensure brevity in your answer.  1. What is the ratio of the General Parity Index (GPI) in Thailand in 1981 to that in 1991?
Your answer should be compact. 0.99. What is the ratio of the General Parity Index (GPI) of Malta in 1981 to that in 1992?
Your answer should be very brief. 0.99. What is the ratio of the General Parity Index (GPI) of Nigeria in 1981 to that in 1992?
Your answer should be very brief. 0.98. What is the ratio of the General Parity Index (GPI) of Philippines in 1981 to that in 1992?
Your response must be concise. 0.99. What is the ratio of the General Parity Index (GPI) in Thailand in 1981 to that in 1992?
Your answer should be compact. 0.98. What is the ratio of the General Parity Index (GPI) of Malta in 1981 to that in 1993?
Make the answer very short. 0.98. What is the ratio of the General Parity Index (GPI) in Philippines in 1981 to that in 1993?
Give a very brief answer. 0.99. What is the ratio of the General Parity Index (GPI) in Thailand in 1981 to that in 1993?
Offer a terse response. 0.98. What is the ratio of the General Parity Index (GPI) in Malta in 1981 to that in 1999?
Your response must be concise. 0.96. What is the ratio of the General Parity Index (GPI) in Nigeria in 1981 to that in 1999?
Your answer should be very brief. 0.99. What is the ratio of the General Parity Index (GPI) in Philippines in 1981 to that in 1999?
Give a very brief answer. 0.99. What is the ratio of the General Parity Index (GPI) in Thailand in 1981 to that in 1999?
Your answer should be compact. 0.99. What is the ratio of the General Parity Index (GPI) in Malta in 1981 to that in 2001?
Your answer should be compact. 0.97. What is the ratio of the General Parity Index (GPI) in Nigeria in 1981 to that in 2001?
Your answer should be very brief. 0.96. What is the ratio of the General Parity Index (GPI) of Philippines in 1981 to that in 2001?
Keep it short and to the point. 0.99. What is the ratio of the General Parity Index (GPI) of Thailand in 1981 to that in 2001?
Provide a succinct answer. 0.98. What is the ratio of the General Parity Index (GPI) in Malta in 1981 to that in 2002?
Offer a terse response. 0.98. What is the ratio of the General Parity Index (GPI) in Nigeria in 1981 to that in 2002?
Give a very brief answer. 0.96. What is the ratio of the General Parity Index (GPI) in Thailand in 1981 to that in 2002?
Give a very brief answer. 0.99. What is the ratio of the General Parity Index (GPI) of Malta in 1981 to that in 2004?
Provide a short and direct response. 0.99. What is the ratio of the General Parity Index (GPI) in Nigeria in 1981 to that in 2004?
Your answer should be very brief. 0.95. What is the ratio of the General Parity Index (GPI) in Thailand in 1981 to that in 2004?
Your answer should be very brief. 0.98. What is the ratio of the General Parity Index (GPI) in Malta in 1991 to that in 1992?
Your response must be concise. 0.99. What is the ratio of the General Parity Index (GPI) in Philippines in 1991 to that in 1992?
Provide a short and direct response. 1. What is the ratio of the General Parity Index (GPI) in Thailand in 1991 to that in 1992?
Your answer should be very brief. 1. What is the ratio of the General Parity Index (GPI) of Malta in 1991 to that in 1993?
Give a very brief answer. 0.98. What is the ratio of the General Parity Index (GPI) of Thailand in 1991 to that in 1993?
Your answer should be compact. 1. What is the ratio of the General Parity Index (GPI) of Malta in 1991 to that in 1999?
Offer a very short reply. 0.97. What is the ratio of the General Parity Index (GPI) in Nigeria in 1991 to that in 1999?
Ensure brevity in your answer.  1. What is the ratio of the General Parity Index (GPI) in Philippines in 1991 to that in 1999?
Make the answer very short. 0.99. What is the ratio of the General Parity Index (GPI) of Thailand in 1991 to that in 1999?
Ensure brevity in your answer.  1.01. What is the ratio of the General Parity Index (GPI) in Malta in 1991 to that in 2001?
Keep it short and to the point. 0.98. What is the ratio of the General Parity Index (GPI) of Nigeria in 1991 to that in 2001?
Provide a short and direct response. 0.97. What is the ratio of the General Parity Index (GPI) of Philippines in 1991 to that in 2001?
Your answer should be compact. 0.99. What is the ratio of the General Parity Index (GPI) in Thailand in 1991 to that in 2001?
Your response must be concise. 1. What is the ratio of the General Parity Index (GPI) in Malta in 1991 to that in 2002?
Your answer should be compact. 0.98. What is the ratio of the General Parity Index (GPI) in Nigeria in 1991 to that in 2002?
Keep it short and to the point. 0.97. What is the ratio of the General Parity Index (GPI) in Malta in 1991 to that in 2004?
Your answer should be compact. 0.99. What is the ratio of the General Parity Index (GPI) of Nigeria in 1991 to that in 2004?
Give a very brief answer. 0.96. What is the ratio of the General Parity Index (GPI) in Philippines in 1991 to that in 2004?
Your answer should be compact. 1.01. What is the ratio of the General Parity Index (GPI) of Nigeria in 1992 to that in 1993?
Make the answer very short. 1.02. What is the ratio of the General Parity Index (GPI) of Philippines in 1992 to that in 1993?
Your response must be concise. 1. What is the ratio of the General Parity Index (GPI) in Malta in 1992 to that in 1999?
Ensure brevity in your answer.  0.97. What is the ratio of the General Parity Index (GPI) in Nigeria in 1992 to that in 1999?
Provide a succinct answer. 1.01. What is the ratio of the General Parity Index (GPI) in Thailand in 1992 to that in 1999?
Provide a short and direct response. 1.01. What is the ratio of the General Parity Index (GPI) in Malta in 1992 to that in 2001?
Provide a short and direct response. 0.98. What is the ratio of the General Parity Index (GPI) in Nigeria in 1992 to that in 2001?
Make the answer very short. 0.99. What is the ratio of the General Parity Index (GPI) of Philippines in 1992 to that in 2001?
Provide a succinct answer. 1. What is the ratio of the General Parity Index (GPI) of Thailand in 1992 to that in 2001?
Ensure brevity in your answer.  1. What is the ratio of the General Parity Index (GPI) of Nigeria in 1992 to that in 2002?
Ensure brevity in your answer.  0.99. What is the ratio of the General Parity Index (GPI) in Philippines in 1992 to that in 2002?
Give a very brief answer. 1.01. What is the ratio of the General Parity Index (GPI) in Thailand in 1992 to that in 2002?
Keep it short and to the point. 1. What is the ratio of the General Parity Index (GPI) of Nigeria in 1992 to that in 2004?
Keep it short and to the point. 0.97. What is the ratio of the General Parity Index (GPI) of Philippines in 1992 to that in 2004?
Your answer should be very brief. 1.01. What is the ratio of the General Parity Index (GPI) in Malta in 1993 to that in 1999?
Your response must be concise. 0.98. What is the ratio of the General Parity Index (GPI) of Nigeria in 1993 to that in 1999?
Offer a very short reply. 1. What is the ratio of the General Parity Index (GPI) in Philippines in 1993 to that in 1999?
Your answer should be compact. 1. What is the ratio of the General Parity Index (GPI) of Thailand in 1993 to that in 1999?
Ensure brevity in your answer.  1.01. What is the ratio of the General Parity Index (GPI) of Nigeria in 1993 to that in 2001?
Your response must be concise. 0.97. What is the ratio of the General Parity Index (GPI) of Thailand in 1993 to that in 2001?
Give a very brief answer. 1. What is the ratio of the General Parity Index (GPI) of Nigeria in 1993 to that in 2002?
Your response must be concise. 0.97. What is the ratio of the General Parity Index (GPI) in Nigeria in 1993 to that in 2004?
Provide a succinct answer. 0.96. What is the ratio of the General Parity Index (GPI) of Philippines in 1993 to that in 2004?
Provide a succinct answer. 1.01. What is the ratio of the General Parity Index (GPI) of Malta in 1999 to that in 2001?
Make the answer very short. 1.01. What is the ratio of the General Parity Index (GPI) of Nigeria in 1999 to that in 2001?
Provide a succinct answer. 0.98. What is the ratio of the General Parity Index (GPI) of Philippines in 1999 to that in 2001?
Offer a terse response. 1. What is the ratio of the General Parity Index (GPI) of Malta in 1999 to that in 2002?
Give a very brief answer. 1.02. What is the ratio of the General Parity Index (GPI) in Nigeria in 1999 to that in 2002?
Make the answer very short. 0.98. What is the ratio of the General Parity Index (GPI) of Philippines in 1999 to that in 2002?
Your answer should be compact. 1.01. What is the ratio of the General Parity Index (GPI) of Malta in 1999 to that in 2004?
Give a very brief answer. 1.02. What is the ratio of the General Parity Index (GPI) in Nigeria in 1999 to that in 2004?
Your answer should be compact. 0.96. What is the ratio of the General Parity Index (GPI) of Philippines in 1999 to that in 2004?
Your response must be concise. 1.01. What is the ratio of the General Parity Index (GPI) of Thailand in 1999 to that in 2004?
Your response must be concise. 0.99. What is the ratio of the General Parity Index (GPI) of Malta in 2001 to that in 2002?
Your answer should be very brief. 1.01. What is the ratio of the General Parity Index (GPI) of Philippines in 2001 to that in 2002?
Provide a succinct answer. 1.01. What is the ratio of the General Parity Index (GPI) of Malta in 2001 to that in 2004?
Your answer should be compact. 1.01. What is the ratio of the General Parity Index (GPI) in Nigeria in 2001 to that in 2004?
Offer a very short reply. 0.99. What is the ratio of the General Parity Index (GPI) of Philippines in 2001 to that in 2004?
Offer a terse response. 1.01. What is the ratio of the General Parity Index (GPI) in Malta in 2002 to that in 2004?
Provide a succinct answer. 1. What is the ratio of the General Parity Index (GPI) in Nigeria in 2002 to that in 2004?
Ensure brevity in your answer.  0.98. What is the ratio of the General Parity Index (GPI) of Philippines in 2002 to that in 2004?
Give a very brief answer. 1. What is the ratio of the General Parity Index (GPI) of Thailand in 2002 to that in 2004?
Ensure brevity in your answer.  1. What is the difference between the highest and the second highest General Parity Index (GPI) of Malta?
Give a very brief answer. 0.01. What is the difference between the highest and the second highest General Parity Index (GPI) of Nigeria?
Your answer should be compact. 0.01. What is the difference between the highest and the second highest General Parity Index (GPI) of Philippines?
Provide a succinct answer. 0. What is the difference between the highest and the second highest General Parity Index (GPI) in Thailand?
Offer a very short reply. 0. What is the difference between the highest and the lowest General Parity Index (GPI) in Malta?
Keep it short and to the point. 0.04. What is the difference between the highest and the lowest General Parity Index (GPI) in Nigeria?
Ensure brevity in your answer.  0.04. What is the difference between the highest and the lowest General Parity Index (GPI) in Philippines?
Your answer should be compact. 0.01. What is the difference between the highest and the lowest General Parity Index (GPI) in Thailand?
Offer a terse response. 0.02. 